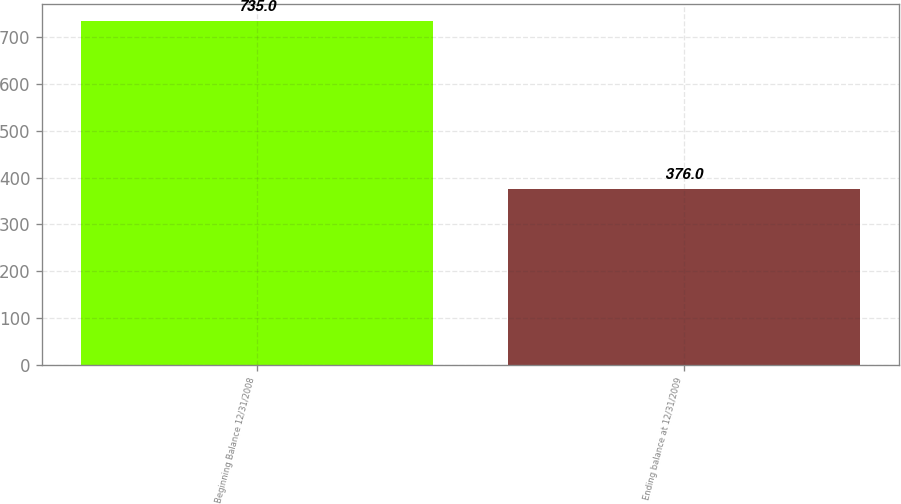<chart> <loc_0><loc_0><loc_500><loc_500><bar_chart><fcel>Beginning Balance 12/31/2008<fcel>Ending balance at 12/31/2009<nl><fcel>735<fcel>376<nl></chart> 